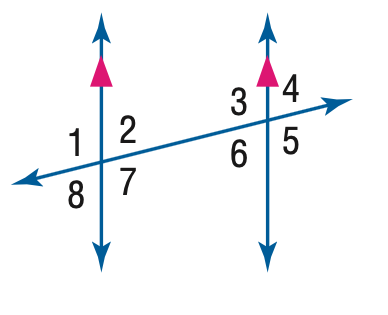Answer the mathemtical geometry problem and directly provide the correct option letter.
Question: In the figure, m \angle 1 = 94. Find the measure of \angle 3.
Choices: A: 76 B: 86 C: 94 D: 96 C 